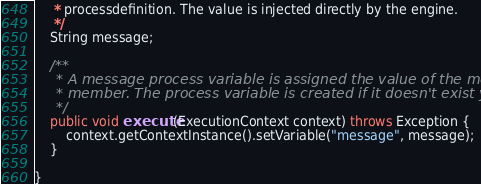<code> <loc_0><loc_0><loc_500><loc_500><_Java_>	 * processdefinition. The value is injected directly by the engine. 
	 */
	String message;

	/**
	 * A message process variable is assigned the value of the message
	 * member. The process variable is created if it doesn't exist yet.
	 */
	public void execute(ExecutionContext context) throws Exception {
		context.getContextInstance().setVariable("message", message);
	}

}
</code> 